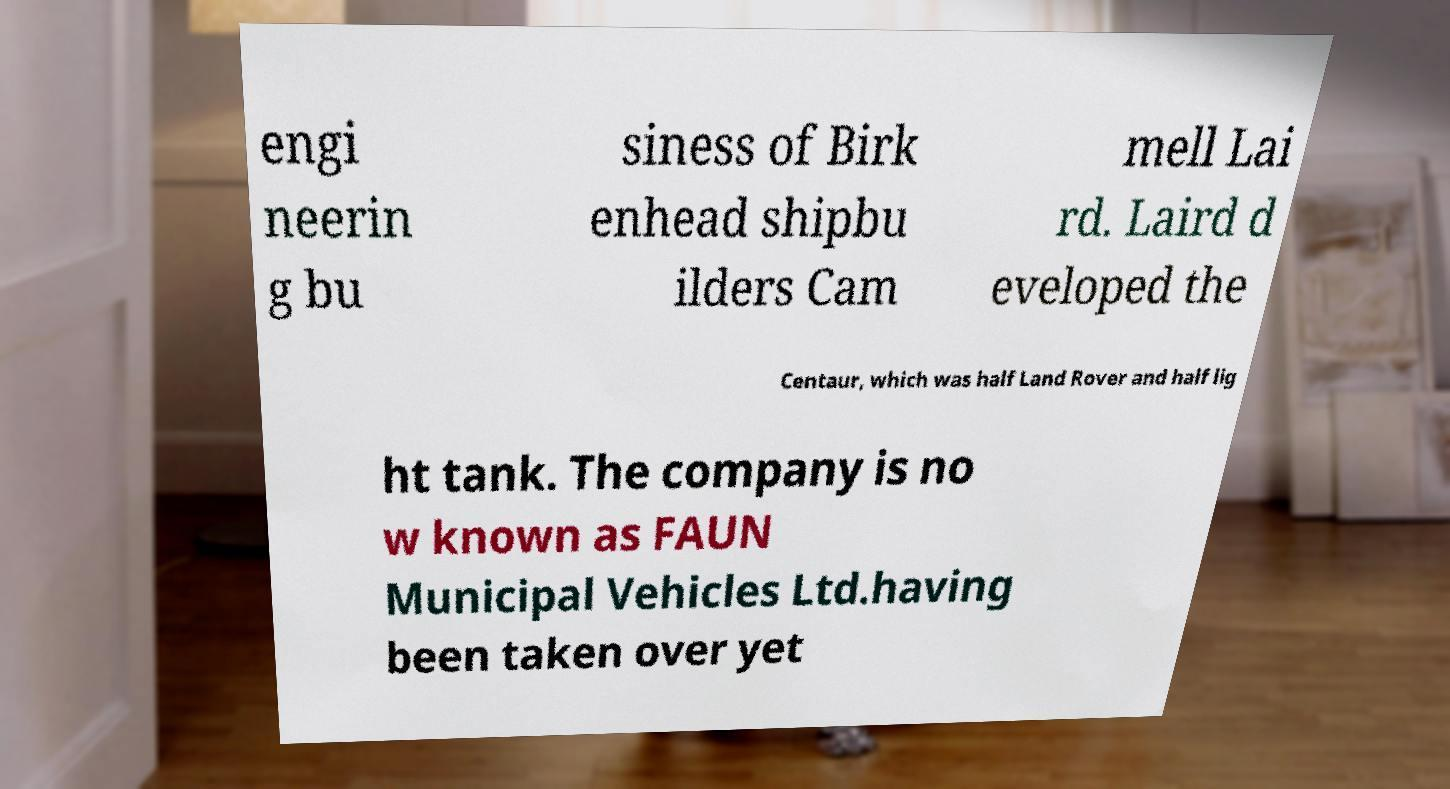Please identify and transcribe the text found in this image. engi neerin g bu siness of Birk enhead shipbu ilders Cam mell Lai rd. Laird d eveloped the Centaur, which was half Land Rover and half lig ht tank. The company is no w known as FAUN Municipal Vehicles Ltd.having been taken over yet 